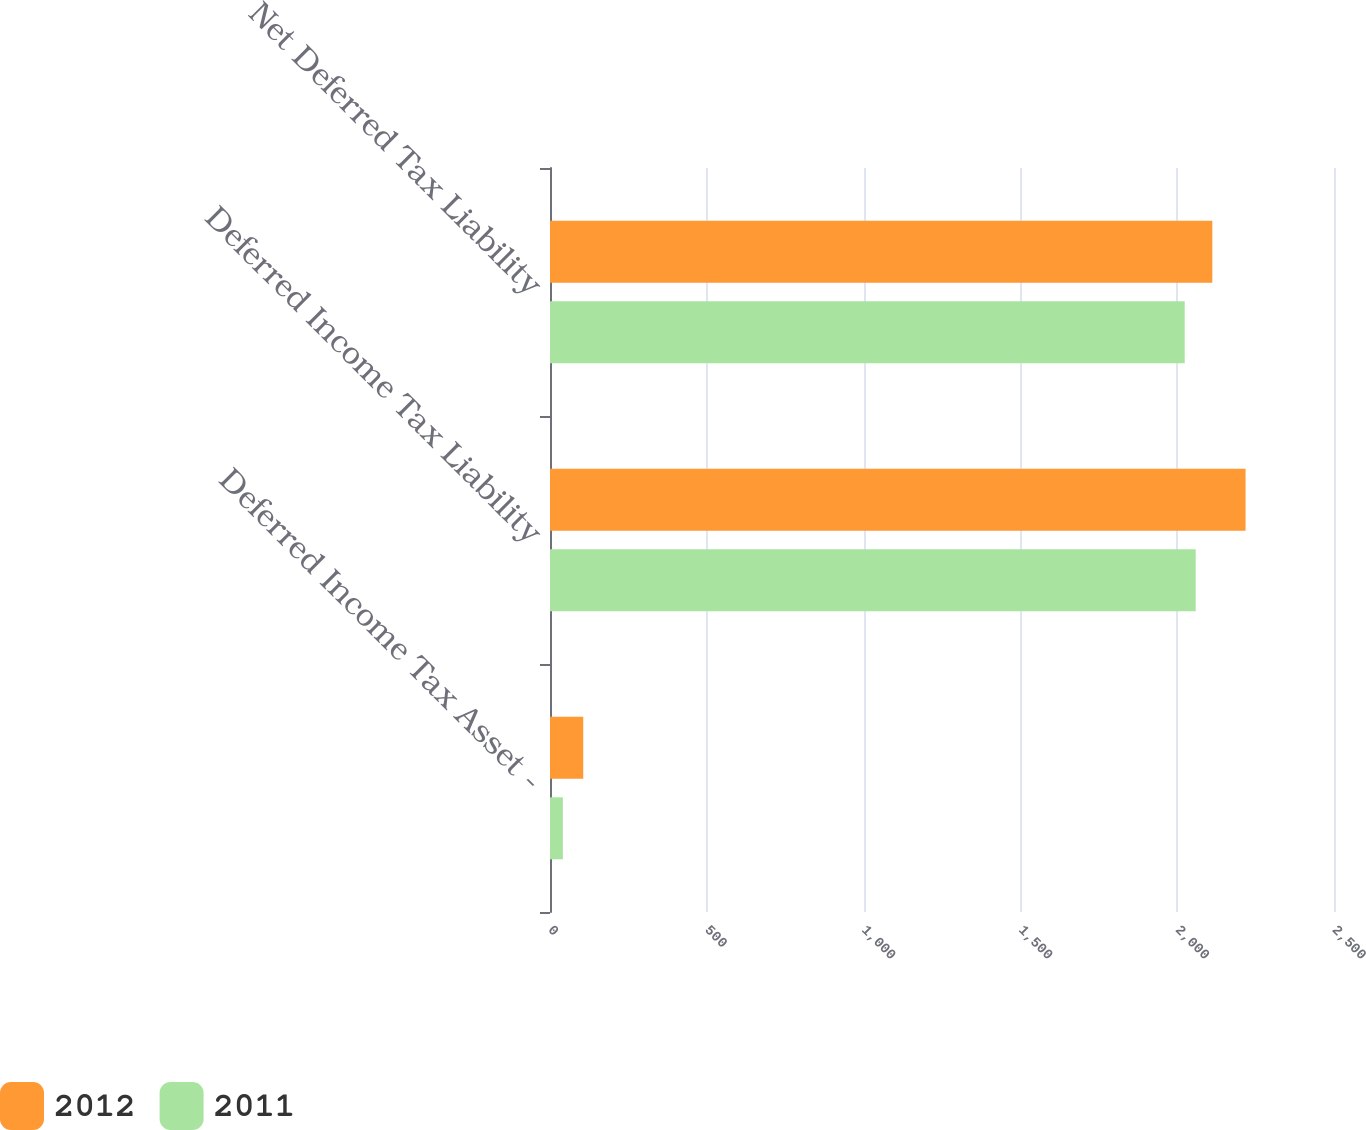Convert chart to OTSL. <chart><loc_0><loc_0><loc_500><loc_500><stacked_bar_chart><ecel><fcel>Deferred Income Tax Asset -<fcel>Deferred Income Tax Liability<fcel>Net Deferred Tax Liability<nl><fcel>2012<fcel>106<fcel>2218<fcel>2112<nl><fcel>2011<fcel>41<fcel>2059<fcel>2024<nl></chart> 